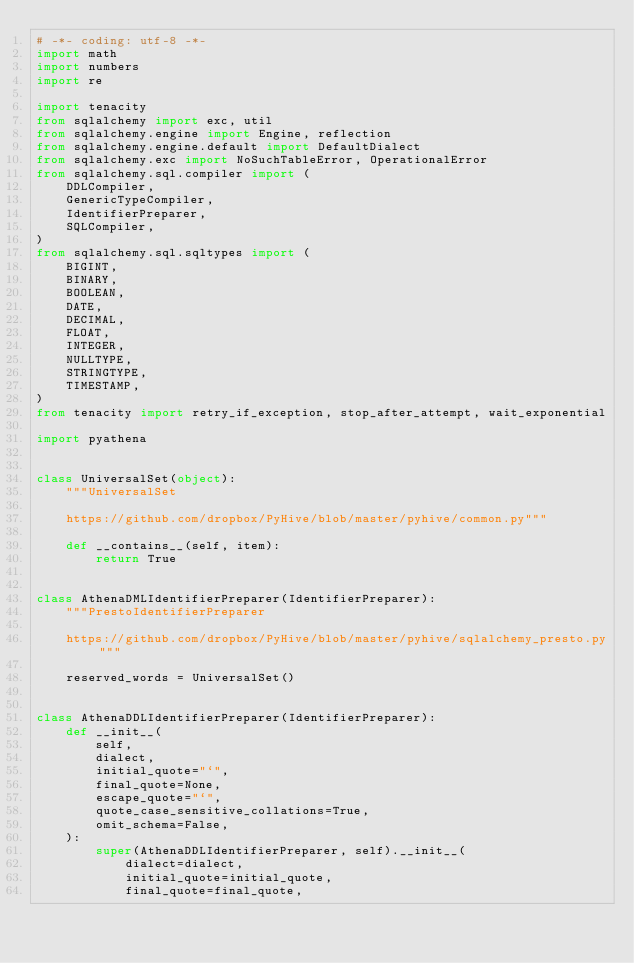<code> <loc_0><loc_0><loc_500><loc_500><_Python_># -*- coding: utf-8 -*-
import math
import numbers
import re

import tenacity
from sqlalchemy import exc, util
from sqlalchemy.engine import Engine, reflection
from sqlalchemy.engine.default import DefaultDialect
from sqlalchemy.exc import NoSuchTableError, OperationalError
from sqlalchemy.sql.compiler import (
    DDLCompiler,
    GenericTypeCompiler,
    IdentifierPreparer,
    SQLCompiler,
)
from sqlalchemy.sql.sqltypes import (
    BIGINT,
    BINARY,
    BOOLEAN,
    DATE,
    DECIMAL,
    FLOAT,
    INTEGER,
    NULLTYPE,
    STRINGTYPE,
    TIMESTAMP,
)
from tenacity import retry_if_exception, stop_after_attempt, wait_exponential

import pyathena


class UniversalSet(object):
    """UniversalSet

    https://github.com/dropbox/PyHive/blob/master/pyhive/common.py"""

    def __contains__(self, item):
        return True


class AthenaDMLIdentifierPreparer(IdentifierPreparer):
    """PrestoIdentifierPreparer

    https://github.com/dropbox/PyHive/blob/master/pyhive/sqlalchemy_presto.py"""

    reserved_words = UniversalSet()


class AthenaDDLIdentifierPreparer(IdentifierPreparer):
    def __init__(
        self,
        dialect,
        initial_quote="`",
        final_quote=None,
        escape_quote="`",
        quote_case_sensitive_collations=True,
        omit_schema=False,
    ):
        super(AthenaDDLIdentifierPreparer, self).__init__(
            dialect=dialect,
            initial_quote=initial_quote,
            final_quote=final_quote,</code> 